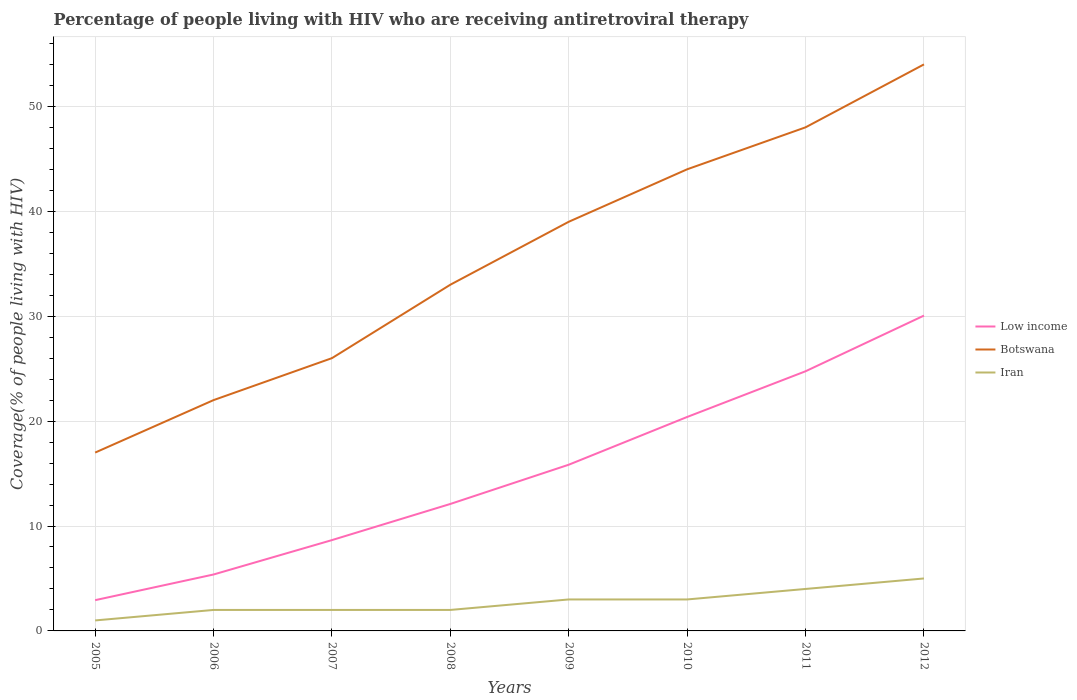Does the line corresponding to Low income intersect with the line corresponding to Iran?
Offer a very short reply. No. Across all years, what is the maximum percentage of the HIV infected people who are receiving antiretroviral therapy in Iran?
Offer a terse response. 1. What is the total percentage of the HIV infected people who are receiving antiretroviral therapy in Low income in the graph?
Your answer should be compact. -14.21. What is the difference between the highest and the second highest percentage of the HIV infected people who are receiving antiretroviral therapy in Iran?
Ensure brevity in your answer.  4. What is the difference between the highest and the lowest percentage of the HIV infected people who are receiving antiretroviral therapy in Iran?
Make the answer very short. 4. Is the percentage of the HIV infected people who are receiving antiretroviral therapy in Botswana strictly greater than the percentage of the HIV infected people who are receiving antiretroviral therapy in Low income over the years?
Provide a short and direct response. No. How many lines are there?
Keep it short and to the point. 3. How many years are there in the graph?
Keep it short and to the point. 8. Are the values on the major ticks of Y-axis written in scientific E-notation?
Provide a succinct answer. No. Where does the legend appear in the graph?
Offer a very short reply. Center right. What is the title of the graph?
Your response must be concise. Percentage of people living with HIV who are receiving antiretroviral therapy. Does "Iraq" appear as one of the legend labels in the graph?
Your response must be concise. No. What is the label or title of the Y-axis?
Your response must be concise. Coverage(% of people living with HIV). What is the Coverage(% of people living with HIV) in Low income in 2005?
Your answer should be compact. 2.93. What is the Coverage(% of people living with HIV) of Botswana in 2005?
Offer a very short reply. 17. What is the Coverage(% of people living with HIV) in Iran in 2005?
Ensure brevity in your answer.  1. What is the Coverage(% of people living with HIV) in Low income in 2006?
Your answer should be compact. 5.38. What is the Coverage(% of people living with HIV) in Botswana in 2006?
Ensure brevity in your answer.  22. What is the Coverage(% of people living with HIV) in Low income in 2007?
Ensure brevity in your answer.  8.66. What is the Coverage(% of people living with HIV) of Botswana in 2007?
Ensure brevity in your answer.  26. What is the Coverage(% of people living with HIV) in Low income in 2008?
Ensure brevity in your answer.  12.1. What is the Coverage(% of people living with HIV) of Botswana in 2008?
Your response must be concise. 33. What is the Coverage(% of people living with HIV) in Low income in 2009?
Your response must be concise. 15.84. What is the Coverage(% of people living with HIV) of Low income in 2010?
Give a very brief answer. 20.39. What is the Coverage(% of people living with HIV) in Low income in 2011?
Ensure brevity in your answer.  24.75. What is the Coverage(% of people living with HIV) in Iran in 2011?
Your response must be concise. 4. What is the Coverage(% of people living with HIV) of Low income in 2012?
Provide a short and direct response. 30.06. What is the Coverage(% of people living with HIV) of Botswana in 2012?
Give a very brief answer. 54. Across all years, what is the maximum Coverage(% of people living with HIV) of Low income?
Your answer should be compact. 30.06. Across all years, what is the minimum Coverage(% of people living with HIV) in Low income?
Your response must be concise. 2.93. Across all years, what is the minimum Coverage(% of people living with HIV) of Botswana?
Provide a succinct answer. 17. What is the total Coverage(% of people living with HIV) in Low income in the graph?
Make the answer very short. 120.11. What is the total Coverage(% of people living with HIV) in Botswana in the graph?
Keep it short and to the point. 283. What is the total Coverage(% of people living with HIV) of Iran in the graph?
Offer a very short reply. 22. What is the difference between the Coverage(% of people living with HIV) in Low income in 2005 and that in 2006?
Make the answer very short. -2.45. What is the difference between the Coverage(% of people living with HIV) in Low income in 2005 and that in 2007?
Your answer should be very brief. -5.73. What is the difference between the Coverage(% of people living with HIV) in Botswana in 2005 and that in 2007?
Provide a short and direct response. -9. What is the difference between the Coverage(% of people living with HIV) of Low income in 2005 and that in 2008?
Provide a short and direct response. -9.17. What is the difference between the Coverage(% of people living with HIV) in Botswana in 2005 and that in 2008?
Offer a terse response. -16. What is the difference between the Coverage(% of people living with HIV) of Low income in 2005 and that in 2009?
Your answer should be compact. -12.91. What is the difference between the Coverage(% of people living with HIV) in Botswana in 2005 and that in 2009?
Offer a very short reply. -22. What is the difference between the Coverage(% of people living with HIV) in Low income in 2005 and that in 2010?
Offer a very short reply. -17.46. What is the difference between the Coverage(% of people living with HIV) of Botswana in 2005 and that in 2010?
Give a very brief answer. -27. What is the difference between the Coverage(% of people living with HIV) in Low income in 2005 and that in 2011?
Offer a very short reply. -21.82. What is the difference between the Coverage(% of people living with HIV) in Botswana in 2005 and that in 2011?
Give a very brief answer. -31. What is the difference between the Coverage(% of people living with HIV) in Low income in 2005 and that in 2012?
Offer a very short reply. -27.13. What is the difference between the Coverage(% of people living with HIV) in Botswana in 2005 and that in 2012?
Offer a very short reply. -37. What is the difference between the Coverage(% of people living with HIV) of Low income in 2006 and that in 2007?
Make the answer very short. -3.28. What is the difference between the Coverage(% of people living with HIV) of Botswana in 2006 and that in 2007?
Your answer should be very brief. -4. What is the difference between the Coverage(% of people living with HIV) of Low income in 2006 and that in 2008?
Provide a succinct answer. -6.72. What is the difference between the Coverage(% of people living with HIV) in Iran in 2006 and that in 2008?
Provide a succinct answer. 0. What is the difference between the Coverage(% of people living with HIV) in Low income in 2006 and that in 2009?
Offer a terse response. -10.46. What is the difference between the Coverage(% of people living with HIV) of Iran in 2006 and that in 2009?
Offer a terse response. -1. What is the difference between the Coverage(% of people living with HIV) in Low income in 2006 and that in 2010?
Offer a very short reply. -15.02. What is the difference between the Coverage(% of people living with HIV) of Botswana in 2006 and that in 2010?
Keep it short and to the point. -22. What is the difference between the Coverage(% of people living with HIV) of Low income in 2006 and that in 2011?
Your answer should be very brief. -19.37. What is the difference between the Coverage(% of people living with HIV) of Botswana in 2006 and that in 2011?
Make the answer very short. -26. What is the difference between the Coverage(% of people living with HIV) in Low income in 2006 and that in 2012?
Offer a very short reply. -24.68. What is the difference between the Coverage(% of people living with HIV) in Botswana in 2006 and that in 2012?
Give a very brief answer. -32. What is the difference between the Coverage(% of people living with HIV) in Iran in 2006 and that in 2012?
Give a very brief answer. -3. What is the difference between the Coverage(% of people living with HIV) in Low income in 2007 and that in 2008?
Make the answer very short. -3.45. What is the difference between the Coverage(% of people living with HIV) in Botswana in 2007 and that in 2008?
Provide a short and direct response. -7. What is the difference between the Coverage(% of people living with HIV) of Iran in 2007 and that in 2008?
Provide a succinct answer. 0. What is the difference between the Coverage(% of people living with HIV) in Low income in 2007 and that in 2009?
Offer a very short reply. -7.18. What is the difference between the Coverage(% of people living with HIV) of Botswana in 2007 and that in 2009?
Provide a succinct answer. -13. What is the difference between the Coverage(% of people living with HIV) in Iran in 2007 and that in 2009?
Your answer should be compact. -1. What is the difference between the Coverage(% of people living with HIV) in Low income in 2007 and that in 2010?
Ensure brevity in your answer.  -11.74. What is the difference between the Coverage(% of people living with HIV) of Low income in 2007 and that in 2011?
Your response must be concise. -16.09. What is the difference between the Coverage(% of people living with HIV) of Low income in 2007 and that in 2012?
Make the answer very short. -21.4. What is the difference between the Coverage(% of people living with HIV) of Botswana in 2007 and that in 2012?
Offer a terse response. -28. What is the difference between the Coverage(% of people living with HIV) in Low income in 2008 and that in 2009?
Your answer should be very brief. -3.74. What is the difference between the Coverage(% of people living with HIV) in Botswana in 2008 and that in 2009?
Your response must be concise. -6. What is the difference between the Coverage(% of people living with HIV) of Iran in 2008 and that in 2009?
Offer a very short reply. -1. What is the difference between the Coverage(% of people living with HIV) of Low income in 2008 and that in 2010?
Make the answer very short. -8.29. What is the difference between the Coverage(% of people living with HIV) in Low income in 2008 and that in 2011?
Your answer should be compact. -12.65. What is the difference between the Coverage(% of people living with HIV) of Iran in 2008 and that in 2011?
Ensure brevity in your answer.  -2. What is the difference between the Coverage(% of people living with HIV) in Low income in 2008 and that in 2012?
Offer a very short reply. -17.95. What is the difference between the Coverage(% of people living with HIV) of Botswana in 2008 and that in 2012?
Your response must be concise. -21. What is the difference between the Coverage(% of people living with HIV) of Low income in 2009 and that in 2010?
Make the answer very short. -4.55. What is the difference between the Coverage(% of people living with HIV) of Botswana in 2009 and that in 2010?
Provide a succinct answer. -5. What is the difference between the Coverage(% of people living with HIV) in Iran in 2009 and that in 2010?
Ensure brevity in your answer.  0. What is the difference between the Coverage(% of people living with HIV) of Low income in 2009 and that in 2011?
Keep it short and to the point. -8.91. What is the difference between the Coverage(% of people living with HIV) in Botswana in 2009 and that in 2011?
Make the answer very short. -9. What is the difference between the Coverage(% of people living with HIV) of Low income in 2009 and that in 2012?
Provide a short and direct response. -14.21. What is the difference between the Coverage(% of people living with HIV) in Iran in 2009 and that in 2012?
Your answer should be compact. -2. What is the difference between the Coverage(% of people living with HIV) in Low income in 2010 and that in 2011?
Your answer should be compact. -4.36. What is the difference between the Coverage(% of people living with HIV) in Low income in 2010 and that in 2012?
Provide a short and direct response. -9.66. What is the difference between the Coverage(% of people living with HIV) of Low income in 2011 and that in 2012?
Ensure brevity in your answer.  -5.31. What is the difference between the Coverage(% of people living with HIV) of Botswana in 2011 and that in 2012?
Give a very brief answer. -6. What is the difference between the Coverage(% of people living with HIV) in Low income in 2005 and the Coverage(% of people living with HIV) in Botswana in 2006?
Offer a very short reply. -19.07. What is the difference between the Coverage(% of people living with HIV) in Low income in 2005 and the Coverage(% of people living with HIV) in Iran in 2006?
Offer a very short reply. 0.93. What is the difference between the Coverage(% of people living with HIV) in Low income in 2005 and the Coverage(% of people living with HIV) in Botswana in 2007?
Offer a very short reply. -23.07. What is the difference between the Coverage(% of people living with HIV) of Low income in 2005 and the Coverage(% of people living with HIV) of Iran in 2007?
Ensure brevity in your answer.  0.93. What is the difference between the Coverage(% of people living with HIV) in Botswana in 2005 and the Coverage(% of people living with HIV) in Iran in 2007?
Offer a very short reply. 15. What is the difference between the Coverage(% of people living with HIV) of Low income in 2005 and the Coverage(% of people living with HIV) of Botswana in 2008?
Make the answer very short. -30.07. What is the difference between the Coverage(% of people living with HIV) in Low income in 2005 and the Coverage(% of people living with HIV) in Iran in 2008?
Provide a succinct answer. 0.93. What is the difference between the Coverage(% of people living with HIV) of Botswana in 2005 and the Coverage(% of people living with HIV) of Iran in 2008?
Ensure brevity in your answer.  15. What is the difference between the Coverage(% of people living with HIV) of Low income in 2005 and the Coverage(% of people living with HIV) of Botswana in 2009?
Make the answer very short. -36.07. What is the difference between the Coverage(% of people living with HIV) of Low income in 2005 and the Coverage(% of people living with HIV) of Iran in 2009?
Offer a very short reply. -0.07. What is the difference between the Coverage(% of people living with HIV) in Botswana in 2005 and the Coverage(% of people living with HIV) in Iran in 2009?
Provide a short and direct response. 14. What is the difference between the Coverage(% of people living with HIV) in Low income in 2005 and the Coverage(% of people living with HIV) in Botswana in 2010?
Your answer should be very brief. -41.07. What is the difference between the Coverage(% of people living with HIV) in Low income in 2005 and the Coverage(% of people living with HIV) in Iran in 2010?
Your answer should be very brief. -0.07. What is the difference between the Coverage(% of people living with HIV) of Botswana in 2005 and the Coverage(% of people living with HIV) of Iran in 2010?
Offer a terse response. 14. What is the difference between the Coverage(% of people living with HIV) of Low income in 2005 and the Coverage(% of people living with HIV) of Botswana in 2011?
Your response must be concise. -45.07. What is the difference between the Coverage(% of people living with HIV) in Low income in 2005 and the Coverage(% of people living with HIV) in Iran in 2011?
Your response must be concise. -1.07. What is the difference between the Coverage(% of people living with HIV) of Botswana in 2005 and the Coverage(% of people living with HIV) of Iran in 2011?
Your response must be concise. 13. What is the difference between the Coverage(% of people living with HIV) of Low income in 2005 and the Coverage(% of people living with HIV) of Botswana in 2012?
Make the answer very short. -51.07. What is the difference between the Coverage(% of people living with HIV) of Low income in 2005 and the Coverage(% of people living with HIV) of Iran in 2012?
Your answer should be very brief. -2.07. What is the difference between the Coverage(% of people living with HIV) of Low income in 2006 and the Coverage(% of people living with HIV) of Botswana in 2007?
Your answer should be very brief. -20.62. What is the difference between the Coverage(% of people living with HIV) of Low income in 2006 and the Coverage(% of people living with HIV) of Iran in 2007?
Offer a terse response. 3.38. What is the difference between the Coverage(% of people living with HIV) of Botswana in 2006 and the Coverage(% of people living with HIV) of Iran in 2007?
Give a very brief answer. 20. What is the difference between the Coverage(% of people living with HIV) of Low income in 2006 and the Coverage(% of people living with HIV) of Botswana in 2008?
Give a very brief answer. -27.62. What is the difference between the Coverage(% of people living with HIV) of Low income in 2006 and the Coverage(% of people living with HIV) of Iran in 2008?
Offer a terse response. 3.38. What is the difference between the Coverage(% of people living with HIV) in Low income in 2006 and the Coverage(% of people living with HIV) in Botswana in 2009?
Your answer should be compact. -33.62. What is the difference between the Coverage(% of people living with HIV) of Low income in 2006 and the Coverage(% of people living with HIV) of Iran in 2009?
Your answer should be very brief. 2.38. What is the difference between the Coverage(% of people living with HIV) of Low income in 2006 and the Coverage(% of people living with HIV) of Botswana in 2010?
Offer a terse response. -38.62. What is the difference between the Coverage(% of people living with HIV) in Low income in 2006 and the Coverage(% of people living with HIV) in Iran in 2010?
Your answer should be very brief. 2.38. What is the difference between the Coverage(% of people living with HIV) in Botswana in 2006 and the Coverage(% of people living with HIV) in Iran in 2010?
Your answer should be very brief. 19. What is the difference between the Coverage(% of people living with HIV) of Low income in 2006 and the Coverage(% of people living with HIV) of Botswana in 2011?
Your answer should be compact. -42.62. What is the difference between the Coverage(% of people living with HIV) of Low income in 2006 and the Coverage(% of people living with HIV) of Iran in 2011?
Offer a terse response. 1.38. What is the difference between the Coverage(% of people living with HIV) of Low income in 2006 and the Coverage(% of people living with HIV) of Botswana in 2012?
Ensure brevity in your answer.  -48.62. What is the difference between the Coverage(% of people living with HIV) in Low income in 2006 and the Coverage(% of people living with HIV) in Iran in 2012?
Offer a terse response. 0.38. What is the difference between the Coverage(% of people living with HIV) in Low income in 2007 and the Coverage(% of people living with HIV) in Botswana in 2008?
Your response must be concise. -24.34. What is the difference between the Coverage(% of people living with HIV) of Low income in 2007 and the Coverage(% of people living with HIV) of Iran in 2008?
Make the answer very short. 6.66. What is the difference between the Coverage(% of people living with HIV) of Botswana in 2007 and the Coverage(% of people living with HIV) of Iran in 2008?
Your response must be concise. 24. What is the difference between the Coverage(% of people living with HIV) in Low income in 2007 and the Coverage(% of people living with HIV) in Botswana in 2009?
Keep it short and to the point. -30.34. What is the difference between the Coverage(% of people living with HIV) of Low income in 2007 and the Coverage(% of people living with HIV) of Iran in 2009?
Make the answer very short. 5.66. What is the difference between the Coverage(% of people living with HIV) in Low income in 2007 and the Coverage(% of people living with HIV) in Botswana in 2010?
Offer a terse response. -35.34. What is the difference between the Coverage(% of people living with HIV) in Low income in 2007 and the Coverage(% of people living with HIV) in Iran in 2010?
Your response must be concise. 5.66. What is the difference between the Coverage(% of people living with HIV) in Botswana in 2007 and the Coverage(% of people living with HIV) in Iran in 2010?
Make the answer very short. 23. What is the difference between the Coverage(% of people living with HIV) of Low income in 2007 and the Coverage(% of people living with HIV) of Botswana in 2011?
Ensure brevity in your answer.  -39.34. What is the difference between the Coverage(% of people living with HIV) in Low income in 2007 and the Coverage(% of people living with HIV) in Iran in 2011?
Offer a terse response. 4.66. What is the difference between the Coverage(% of people living with HIV) in Botswana in 2007 and the Coverage(% of people living with HIV) in Iran in 2011?
Make the answer very short. 22. What is the difference between the Coverage(% of people living with HIV) of Low income in 2007 and the Coverage(% of people living with HIV) of Botswana in 2012?
Your answer should be very brief. -45.34. What is the difference between the Coverage(% of people living with HIV) in Low income in 2007 and the Coverage(% of people living with HIV) in Iran in 2012?
Your answer should be very brief. 3.66. What is the difference between the Coverage(% of people living with HIV) in Low income in 2008 and the Coverage(% of people living with HIV) in Botswana in 2009?
Provide a short and direct response. -26.9. What is the difference between the Coverage(% of people living with HIV) of Low income in 2008 and the Coverage(% of people living with HIV) of Iran in 2009?
Keep it short and to the point. 9.1. What is the difference between the Coverage(% of people living with HIV) in Botswana in 2008 and the Coverage(% of people living with HIV) in Iran in 2009?
Offer a very short reply. 30. What is the difference between the Coverage(% of people living with HIV) of Low income in 2008 and the Coverage(% of people living with HIV) of Botswana in 2010?
Provide a short and direct response. -31.9. What is the difference between the Coverage(% of people living with HIV) in Low income in 2008 and the Coverage(% of people living with HIV) in Iran in 2010?
Your answer should be compact. 9.1. What is the difference between the Coverage(% of people living with HIV) of Botswana in 2008 and the Coverage(% of people living with HIV) of Iran in 2010?
Your answer should be compact. 30. What is the difference between the Coverage(% of people living with HIV) in Low income in 2008 and the Coverage(% of people living with HIV) in Botswana in 2011?
Your response must be concise. -35.9. What is the difference between the Coverage(% of people living with HIV) in Low income in 2008 and the Coverage(% of people living with HIV) in Iran in 2011?
Your answer should be very brief. 8.1. What is the difference between the Coverage(% of people living with HIV) in Low income in 2008 and the Coverage(% of people living with HIV) in Botswana in 2012?
Ensure brevity in your answer.  -41.9. What is the difference between the Coverage(% of people living with HIV) of Low income in 2008 and the Coverage(% of people living with HIV) of Iran in 2012?
Keep it short and to the point. 7.1. What is the difference between the Coverage(% of people living with HIV) of Low income in 2009 and the Coverage(% of people living with HIV) of Botswana in 2010?
Your answer should be compact. -28.16. What is the difference between the Coverage(% of people living with HIV) in Low income in 2009 and the Coverage(% of people living with HIV) in Iran in 2010?
Make the answer very short. 12.84. What is the difference between the Coverage(% of people living with HIV) of Botswana in 2009 and the Coverage(% of people living with HIV) of Iran in 2010?
Keep it short and to the point. 36. What is the difference between the Coverage(% of people living with HIV) in Low income in 2009 and the Coverage(% of people living with HIV) in Botswana in 2011?
Your response must be concise. -32.16. What is the difference between the Coverage(% of people living with HIV) in Low income in 2009 and the Coverage(% of people living with HIV) in Iran in 2011?
Provide a short and direct response. 11.84. What is the difference between the Coverage(% of people living with HIV) in Low income in 2009 and the Coverage(% of people living with HIV) in Botswana in 2012?
Offer a very short reply. -38.16. What is the difference between the Coverage(% of people living with HIV) in Low income in 2009 and the Coverage(% of people living with HIV) in Iran in 2012?
Provide a short and direct response. 10.84. What is the difference between the Coverage(% of people living with HIV) in Botswana in 2009 and the Coverage(% of people living with HIV) in Iran in 2012?
Offer a very short reply. 34. What is the difference between the Coverage(% of people living with HIV) of Low income in 2010 and the Coverage(% of people living with HIV) of Botswana in 2011?
Provide a succinct answer. -27.61. What is the difference between the Coverage(% of people living with HIV) of Low income in 2010 and the Coverage(% of people living with HIV) of Iran in 2011?
Offer a very short reply. 16.39. What is the difference between the Coverage(% of people living with HIV) of Botswana in 2010 and the Coverage(% of people living with HIV) of Iran in 2011?
Keep it short and to the point. 40. What is the difference between the Coverage(% of people living with HIV) of Low income in 2010 and the Coverage(% of people living with HIV) of Botswana in 2012?
Your answer should be compact. -33.61. What is the difference between the Coverage(% of people living with HIV) in Low income in 2010 and the Coverage(% of people living with HIV) in Iran in 2012?
Provide a short and direct response. 15.39. What is the difference between the Coverage(% of people living with HIV) in Botswana in 2010 and the Coverage(% of people living with HIV) in Iran in 2012?
Provide a succinct answer. 39. What is the difference between the Coverage(% of people living with HIV) of Low income in 2011 and the Coverage(% of people living with HIV) of Botswana in 2012?
Give a very brief answer. -29.25. What is the difference between the Coverage(% of people living with HIV) of Low income in 2011 and the Coverage(% of people living with HIV) of Iran in 2012?
Give a very brief answer. 19.75. What is the difference between the Coverage(% of people living with HIV) of Botswana in 2011 and the Coverage(% of people living with HIV) of Iran in 2012?
Your answer should be very brief. 43. What is the average Coverage(% of people living with HIV) of Low income per year?
Keep it short and to the point. 15.01. What is the average Coverage(% of people living with HIV) of Botswana per year?
Offer a terse response. 35.38. What is the average Coverage(% of people living with HIV) of Iran per year?
Offer a very short reply. 2.75. In the year 2005, what is the difference between the Coverage(% of people living with HIV) in Low income and Coverage(% of people living with HIV) in Botswana?
Give a very brief answer. -14.07. In the year 2005, what is the difference between the Coverage(% of people living with HIV) in Low income and Coverage(% of people living with HIV) in Iran?
Your answer should be very brief. 1.93. In the year 2005, what is the difference between the Coverage(% of people living with HIV) in Botswana and Coverage(% of people living with HIV) in Iran?
Your answer should be very brief. 16. In the year 2006, what is the difference between the Coverage(% of people living with HIV) in Low income and Coverage(% of people living with HIV) in Botswana?
Provide a short and direct response. -16.62. In the year 2006, what is the difference between the Coverage(% of people living with HIV) in Low income and Coverage(% of people living with HIV) in Iran?
Your answer should be compact. 3.38. In the year 2006, what is the difference between the Coverage(% of people living with HIV) in Botswana and Coverage(% of people living with HIV) in Iran?
Offer a very short reply. 20. In the year 2007, what is the difference between the Coverage(% of people living with HIV) in Low income and Coverage(% of people living with HIV) in Botswana?
Your response must be concise. -17.34. In the year 2007, what is the difference between the Coverage(% of people living with HIV) of Low income and Coverage(% of people living with HIV) of Iran?
Offer a terse response. 6.66. In the year 2007, what is the difference between the Coverage(% of people living with HIV) of Botswana and Coverage(% of people living with HIV) of Iran?
Your answer should be compact. 24. In the year 2008, what is the difference between the Coverage(% of people living with HIV) of Low income and Coverage(% of people living with HIV) of Botswana?
Offer a terse response. -20.9. In the year 2008, what is the difference between the Coverage(% of people living with HIV) of Low income and Coverage(% of people living with HIV) of Iran?
Offer a very short reply. 10.1. In the year 2008, what is the difference between the Coverage(% of people living with HIV) of Botswana and Coverage(% of people living with HIV) of Iran?
Provide a succinct answer. 31. In the year 2009, what is the difference between the Coverage(% of people living with HIV) in Low income and Coverage(% of people living with HIV) in Botswana?
Make the answer very short. -23.16. In the year 2009, what is the difference between the Coverage(% of people living with HIV) of Low income and Coverage(% of people living with HIV) of Iran?
Keep it short and to the point. 12.84. In the year 2010, what is the difference between the Coverage(% of people living with HIV) in Low income and Coverage(% of people living with HIV) in Botswana?
Provide a short and direct response. -23.61. In the year 2010, what is the difference between the Coverage(% of people living with HIV) of Low income and Coverage(% of people living with HIV) of Iran?
Offer a very short reply. 17.39. In the year 2011, what is the difference between the Coverage(% of people living with HIV) of Low income and Coverage(% of people living with HIV) of Botswana?
Your answer should be compact. -23.25. In the year 2011, what is the difference between the Coverage(% of people living with HIV) of Low income and Coverage(% of people living with HIV) of Iran?
Make the answer very short. 20.75. In the year 2012, what is the difference between the Coverage(% of people living with HIV) in Low income and Coverage(% of people living with HIV) in Botswana?
Provide a short and direct response. -23.94. In the year 2012, what is the difference between the Coverage(% of people living with HIV) in Low income and Coverage(% of people living with HIV) in Iran?
Keep it short and to the point. 25.06. What is the ratio of the Coverage(% of people living with HIV) in Low income in 2005 to that in 2006?
Ensure brevity in your answer.  0.55. What is the ratio of the Coverage(% of people living with HIV) of Botswana in 2005 to that in 2006?
Give a very brief answer. 0.77. What is the ratio of the Coverage(% of people living with HIV) of Low income in 2005 to that in 2007?
Your answer should be compact. 0.34. What is the ratio of the Coverage(% of people living with HIV) of Botswana in 2005 to that in 2007?
Keep it short and to the point. 0.65. What is the ratio of the Coverage(% of people living with HIV) of Low income in 2005 to that in 2008?
Your answer should be compact. 0.24. What is the ratio of the Coverage(% of people living with HIV) of Botswana in 2005 to that in 2008?
Provide a short and direct response. 0.52. What is the ratio of the Coverage(% of people living with HIV) in Iran in 2005 to that in 2008?
Make the answer very short. 0.5. What is the ratio of the Coverage(% of people living with HIV) of Low income in 2005 to that in 2009?
Your response must be concise. 0.19. What is the ratio of the Coverage(% of people living with HIV) of Botswana in 2005 to that in 2009?
Keep it short and to the point. 0.44. What is the ratio of the Coverage(% of people living with HIV) of Low income in 2005 to that in 2010?
Your answer should be compact. 0.14. What is the ratio of the Coverage(% of people living with HIV) in Botswana in 2005 to that in 2010?
Your answer should be compact. 0.39. What is the ratio of the Coverage(% of people living with HIV) of Low income in 2005 to that in 2011?
Offer a terse response. 0.12. What is the ratio of the Coverage(% of people living with HIV) in Botswana in 2005 to that in 2011?
Your answer should be compact. 0.35. What is the ratio of the Coverage(% of people living with HIV) of Iran in 2005 to that in 2011?
Your response must be concise. 0.25. What is the ratio of the Coverage(% of people living with HIV) of Low income in 2005 to that in 2012?
Keep it short and to the point. 0.1. What is the ratio of the Coverage(% of people living with HIV) of Botswana in 2005 to that in 2012?
Your answer should be very brief. 0.31. What is the ratio of the Coverage(% of people living with HIV) of Iran in 2005 to that in 2012?
Make the answer very short. 0.2. What is the ratio of the Coverage(% of people living with HIV) in Low income in 2006 to that in 2007?
Your answer should be compact. 0.62. What is the ratio of the Coverage(% of people living with HIV) in Botswana in 2006 to that in 2007?
Your answer should be very brief. 0.85. What is the ratio of the Coverage(% of people living with HIV) in Iran in 2006 to that in 2007?
Offer a terse response. 1. What is the ratio of the Coverage(% of people living with HIV) in Low income in 2006 to that in 2008?
Offer a very short reply. 0.44. What is the ratio of the Coverage(% of people living with HIV) in Iran in 2006 to that in 2008?
Give a very brief answer. 1. What is the ratio of the Coverage(% of people living with HIV) of Low income in 2006 to that in 2009?
Your answer should be compact. 0.34. What is the ratio of the Coverage(% of people living with HIV) of Botswana in 2006 to that in 2009?
Offer a very short reply. 0.56. What is the ratio of the Coverage(% of people living with HIV) in Iran in 2006 to that in 2009?
Provide a short and direct response. 0.67. What is the ratio of the Coverage(% of people living with HIV) of Low income in 2006 to that in 2010?
Your answer should be compact. 0.26. What is the ratio of the Coverage(% of people living with HIV) of Botswana in 2006 to that in 2010?
Offer a terse response. 0.5. What is the ratio of the Coverage(% of people living with HIV) in Iran in 2006 to that in 2010?
Keep it short and to the point. 0.67. What is the ratio of the Coverage(% of people living with HIV) of Low income in 2006 to that in 2011?
Ensure brevity in your answer.  0.22. What is the ratio of the Coverage(% of people living with HIV) in Botswana in 2006 to that in 2011?
Give a very brief answer. 0.46. What is the ratio of the Coverage(% of people living with HIV) in Iran in 2006 to that in 2011?
Offer a terse response. 0.5. What is the ratio of the Coverage(% of people living with HIV) in Low income in 2006 to that in 2012?
Keep it short and to the point. 0.18. What is the ratio of the Coverage(% of people living with HIV) of Botswana in 2006 to that in 2012?
Your answer should be compact. 0.41. What is the ratio of the Coverage(% of people living with HIV) of Low income in 2007 to that in 2008?
Offer a terse response. 0.72. What is the ratio of the Coverage(% of people living with HIV) in Botswana in 2007 to that in 2008?
Your response must be concise. 0.79. What is the ratio of the Coverage(% of people living with HIV) of Low income in 2007 to that in 2009?
Your response must be concise. 0.55. What is the ratio of the Coverage(% of people living with HIV) of Iran in 2007 to that in 2009?
Give a very brief answer. 0.67. What is the ratio of the Coverage(% of people living with HIV) of Low income in 2007 to that in 2010?
Your response must be concise. 0.42. What is the ratio of the Coverage(% of people living with HIV) of Botswana in 2007 to that in 2010?
Your answer should be very brief. 0.59. What is the ratio of the Coverage(% of people living with HIV) of Iran in 2007 to that in 2010?
Your answer should be very brief. 0.67. What is the ratio of the Coverage(% of people living with HIV) in Low income in 2007 to that in 2011?
Make the answer very short. 0.35. What is the ratio of the Coverage(% of people living with HIV) of Botswana in 2007 to that in 2011?
Give a very brief answer. 0.54. What is the ratio of the Coverage(% of people living with HIV) in Low income in 2007 to that in 2012?
Your answer should be very brief. 0.29. What is the ratio of the Coverage(% of people living with HIV) of Botswana in 2007 to that in 2012?
Provide a succinct answer. 0.48. What is the ratio of the Coverage(% of people living with HIV) of Iran in 2007 to that in 2012?
Ensure brevity in your answer.  0.4. What is the ratio of the Coverage(% of people living with HIV) in Low income in 2008 to that in 2009?
Your answer should be compact. 0.76. What is the ratio of the Coverage(% of people living with HIV) in Botswana in 2008 to that in 2009?
Your answer should be very brief. 0.85. What is the ratio of the Coverage(% of people living with HIV) of Iran in 2008 to that in 2009?
Your answer should be compact. 0.67. What is the ratio of the Coverage(% of people living with HIV) in Low income in 2008 to that in 2010?
Your response must be concise. 0.59. What is the ratio of the Coverage(% of people living with HIV) in Botswana in 2008 to that in 2010?
Your answer should be very brief. 0.75. What is the ratio of the Coverage(% of people living with HIV) in Low income in 2008 to that in 2011?
Offer a terse response. 0.49. What is the ratio of the Coverage(% of people living with HIV) in Botswana in 2008 to that in 2011?
Your answer should be very brief. 0.69. What is the ratio of the Coverage(% of people living with HIV) of Iran in 2008 to that in 2011?
Your answer should be compact. 0.5. What is the ratio of the Coverage(% of people living with HIV) of Low income in 2008 to that in 2012?
Offer a very short reply. 0.4. What is the ratio of the Coverage(% of people living with HIV) in Botswana in 2008 to that in 2012?
Provide a short and direct response. 0.61. What is the ratio of the Coverage(% of people living with HIV) of Low income in 2009 to that in 2010?
Your answer should be compact. 0.78. What is the ratio of the Coverage(% of people living with HIV) in Botswana in 2009 to that in 2010?
Offer a terse response. 0.89. What is the ratio of the Coverage(% of people living with HIV) in Iran in 2009 to that in 2010?
Offer a terse response. 1. What is the ratio of the Coverage(% of people living with HIV) in Low income in 2009 to that in 2011?
Offer a terse response. 0.64. What is the ratio of the Coverage(% of people living with HIV) of Botswana in 2009 to that in 2011?
Give a very brief answer. 0.81. What is the ratio of the Coverage(% of people living with HIV) of Iran in 2009 to that in 2011?
Provide a short and direct response. 0.75. What is the ratio of the Coverage(% of people living with HIV) in Low income in 2009 to that in 2012?
Provide a succinct answer. 0.53. What is the ratio of the Coverage(% of people living with HIV) in Botswana in 2009 to that in 2012?
Offer a very short reply. 0.72. What is the ratio of the Coverage(% of people living with HIV) in Iran in 2009 to that in 2012?
Offer a very short reply. 0.6. What is the ratio of the Coverage(% of people living with HIV) in Low income in 2010 to that in 2011?
Ensure brevity in your answer.  0.82. What is the ratio of the Coverage(% of people living with HIV) of Botswana in 2010 to that in 2011?
Keep it short and to the point. 0.92. What is the ratio of the Coverage(% of people living with HIV) in Low income in 2010 to that in 2012?
Offer a terse response. 0.68. What is the ratio of the Coverage(% of people living with HIV) of Botswana in 2010 to that in 2012?
Provide a succinct answer. 0.81. What is the ratio of the Coverage(% of people living with HIV) in Low income in 2011 to that in 2012?
Offer a very short reply. 0.82. What is the ratio of the Coverage(% of people living with HIV) in Botswana in 2011 to that in 2012?
Your answer should be compact. 0.89. What is the difference between the highest and the second highest Coverage(% of people living with HIV) of Low income?
Your answer should be compact. 5.31. What is the difference between the highest and the second highest Coverage(% of people living with HIV) in Botswana?
Your response must be concise. 6. What is the difference between the highest and the second highest Coverage(% of people living with HIV) in Iran?
Your answer should be compact. 1. What is the difference between the highest and the lowest Coverage(% of people living with HIV) in Low income?
Make the answer very short. 27.13. What is the difference between the highest and the lowest Coverage(% of people living with HIV) in Iran?
Your answer should be very brief. 4. 